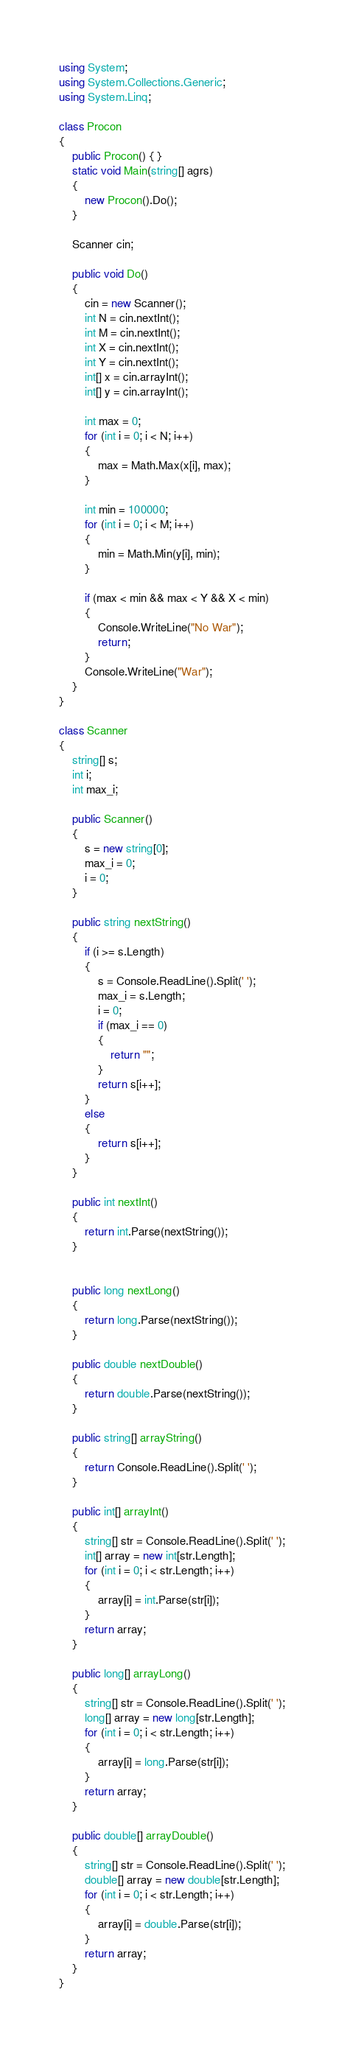<code> <loc_0><loc_0><loc_500><loc_500><_C#_>using System;
using System.Collections.Generic;
using System.Linq;

class Procon
{
    public Procon() { }
    static void Main(string[] agrs)
    {
        new Procon().Do();
    }

    Scanner cin;

    public void Do()
    {
        cin = new Scanner();
        int N = cin.nextInt();
        int M = cin.nextInt();
        int X = cin.nextInt();
        int Y = cin.nextInt();
        int[] x = cin.arrayInt();
        int[] y = cin.arrayInt();

        int max = 0;
        for (int i = 0; i < N; i++)
        {
            max = Math.Max(x[i], max);
        }

        int min = 100000;
        for (int i = 0; i < M; i++)
        {
            min = Math.Min(y[i], min);
        }

        if (max < min && max < Y && X < min)
        {
            Console.WriteLine("No War");
            return;
        }
        Console.WriteLine("War");
    }
}

class Scanner
{
    string[] s;
    int i;
    int max_i;

    public Scanner()
    {
        s = new string[0];
        max_i = 0;
        i = 0;
    }

    public string nextString()
    {
        if (i >= s.Length)
        {
            s = Console.ReadLine().Split(' ');
            max_i = s.Length;
            i = 0;
            if (max_i == 0)
            {
                return "";
            }
            return s[i++];
        }
        else
        {
            return s[i++];
        }
    }

    public int nextInt()
    {
        return int.Parse(nextString());
    }


    public long nextLong()
    {
        return long.Parse(nextString());
    }

    public double nextDouble()
    {
        return double.Parse(nextString());
    }

    public string[] arrayString()
    {
        return Console.ReadLine().Split(' ');
    }

    public int[] arrayInt()
    {
        string[] str = Console.ReadLine().Split(' ');
        int[] array = new int[str.Length];
        for (int i = 0; i < str.Length; i++)
        {
            array[i] = int.Parse(str[i]);
        }
        return array;
    }

    public long[] arrayLong()
    {
        string[] str = Console.ReadLine().Split(' ');
        long[] array = new long[str.Length];
        for (int i = 0; i < str.Length; i++)
        {
            array[i] = long.Parse(str[i]);
        }
        return array;
    }

    public double[] arrayDouble()
    {
        string[] str = Console.ReadLine().Split(' ');
        double[] array = new double[str.Length];
        for (int i = 0; i < str.Length; i++)
        {
            array[i] = double.Parse(str[i]);
        }
        return array;
    }
}
</code> 